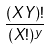Convert formula to latex. <formula><loc_0><loc_0><loc_500><loc_500>\frac { ( X Y ) ! } { ( X ! ) ^ { y } }</formula> 